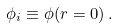<formula> <loc_0><loc_0><loc_500><loc_500>\phi _ { i } \equiv \phi ( r = 0 ) \, .</formula> 